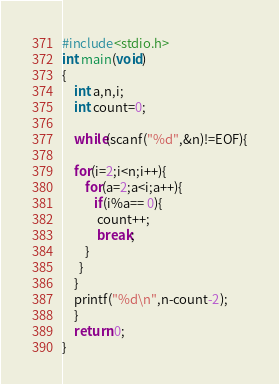<code> <loc_0><loc_0><loc_500><loc_500><_C_>#include<stdio.h>
int main(void)
{
    int a,n,i;
    int count=0;

    while(scanf("%d",&n)!=EOF){

    for(i=2;i<n;i++){
        for(a=2;a<i;a++){
           if(i%a== 0){
            count++;
            break;
        }
      }
    }
    printf("%d\n",n-count-2);
    }
    return 0;
}</code> 